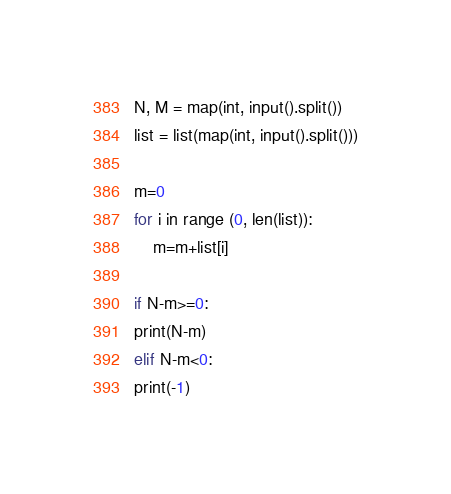Convert code to text. <code><loc_0><loc_0><loc_500><loc_500><_Python_>N, M = map(int, input().split())
list = list(map(int, input().split()))

m=0
for i in range (0, len(list)):
	m=m+list[i]

if N-m>=0:
print(N-m)
elif N-m<0:
print(-1)</code> 